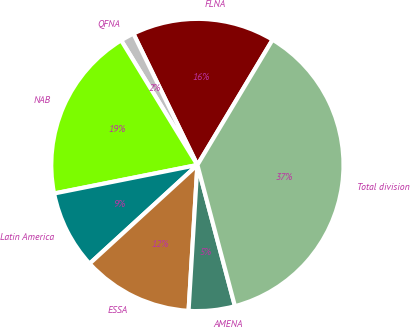<chart> <loc_0><loc_0><loc_500><loc_500><pie_chart><fcel>FLNA<fcel>QFNA<fcel>NAB<fcel>Latin America<fcel>ESSA<fcel>AMENA<fcel>Total division<nl><fcel>15.82%<fcel>1.52%<fcel>19.39%<fcel>8.67%<fcel>12.24%<fcel>5.1%<fcel>37.26%<nl></chart> 